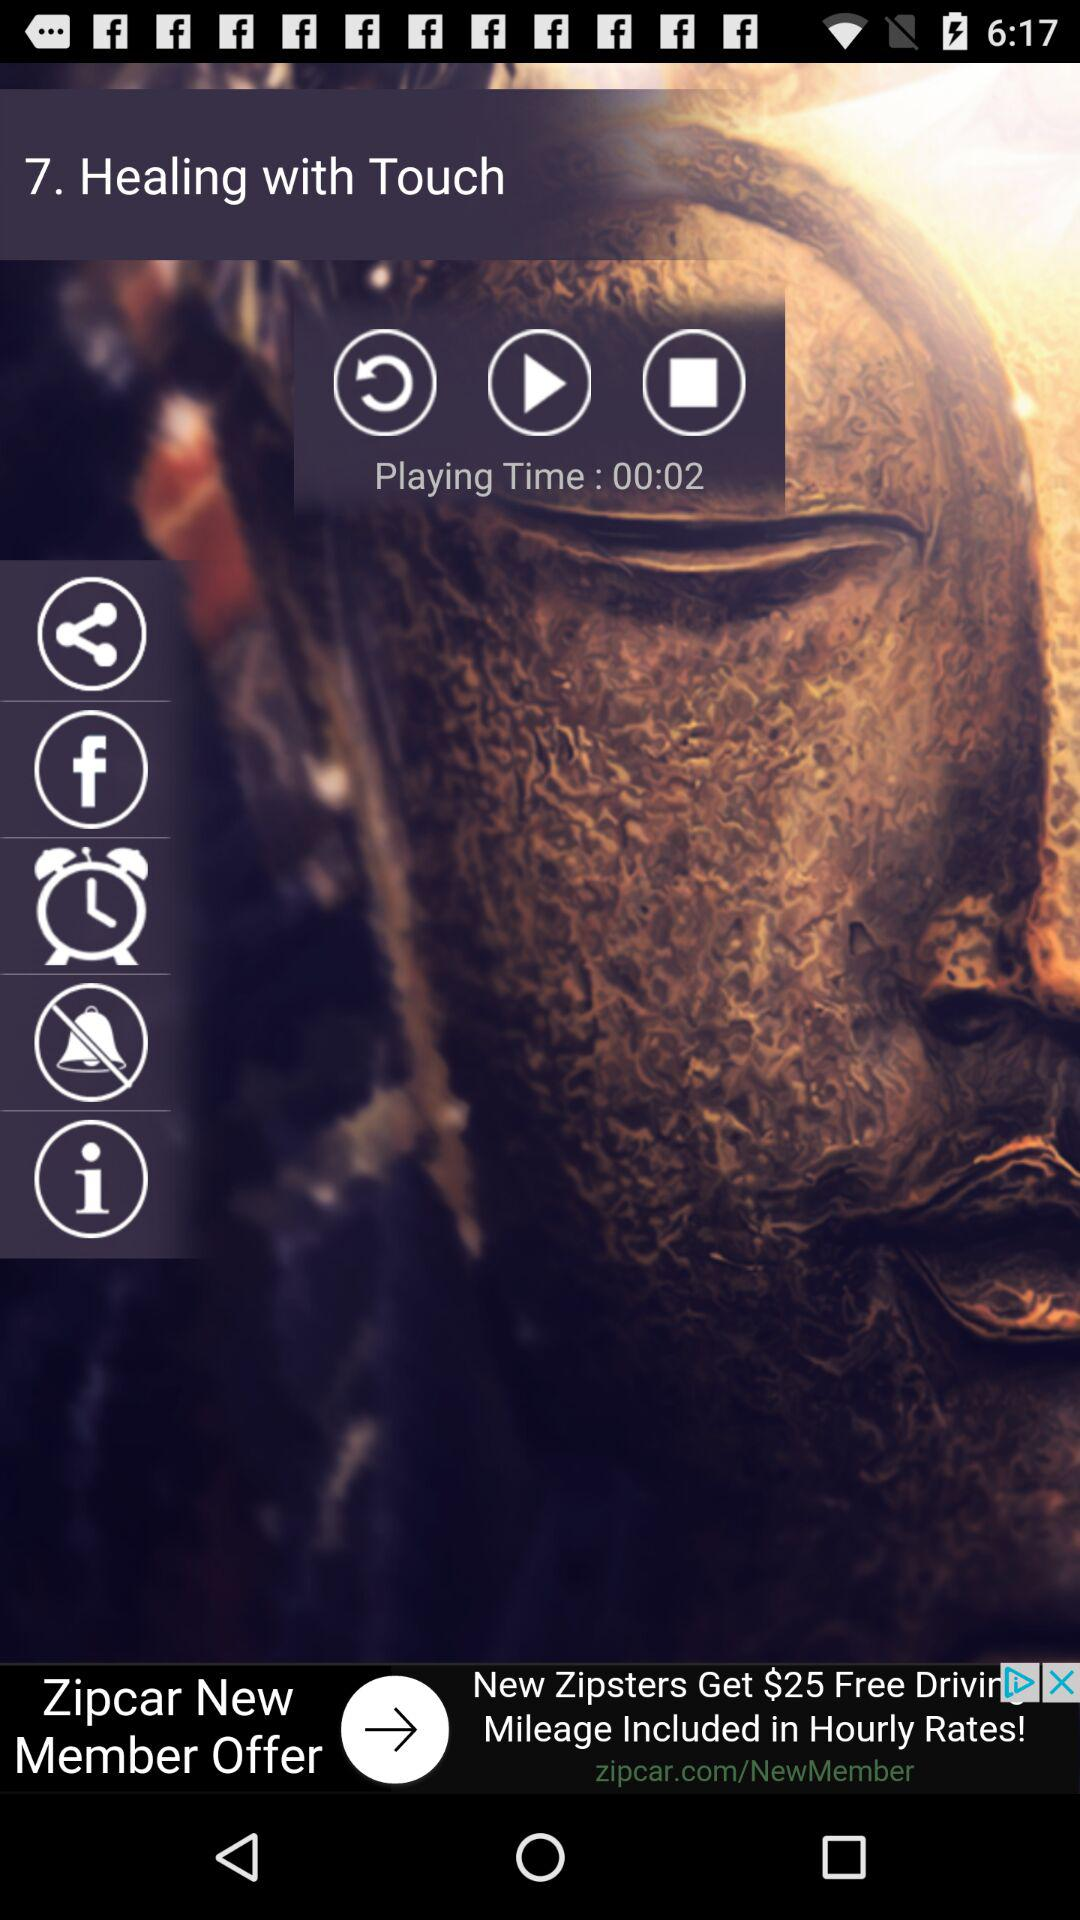What is the playing time? The playing time is 2 seconds. 